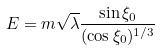<formula> <loc_0><loc_0><loc_500><loc_500>E = m \sqrt { \lambda } \frac { \sin \xi _ { 0 } } { ( \cos \xi _ { 0 } ) ^ { 1 / 3 } }</formula> 